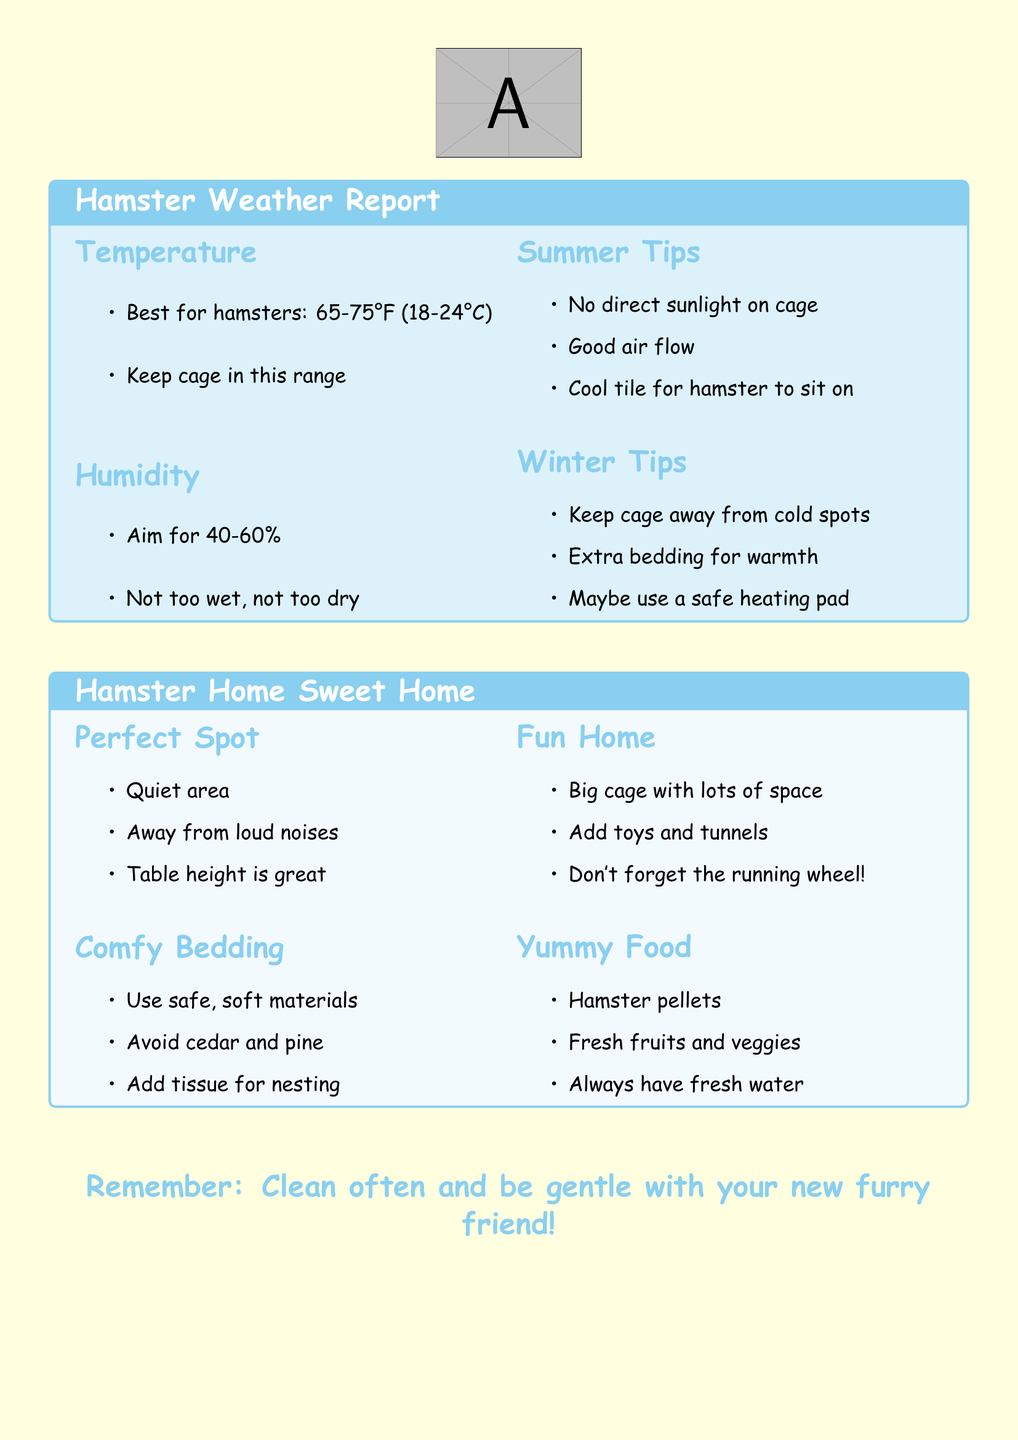what is the best temperature for hamsters? The document states that the best temperature for hamsters is between 65-75°F (18-24°C).
Answer: 65-75°F (18-24°C) what is the ideal humidity level for hamsters? The report indicates that the ideal humidity level should be between 40-60%.
Answer: 40-60% what should you avoid using for bedding? It mentions to avoid cedar and pine for hamster bedding.
Answer: cedar and pine where should you place the hamster cage during summer? The document advises to keep the cage away from direct sunlight.
Answer: away from direct sunlight what extra item can be used for warmth in winter? The report suggests that a safe heating pad can be used for extra warmth.
Answer: safe heating pad what kind of bedding should be used? It states to use safe, soft materials for bedding.
Answer: safe, soft materials how should the hamster's living area be in terms of noise? The document emphasizes that the area should be quiet and away from loud noises.
Answer: quiet what is a fun addition to the hamster's cage? The document recommends adding toys and tunnels for fun.
Answer: toys and tunnels how often should you clean the hamster's cage? The reminder at the end of the document indicates to clean often.
Answer: often 